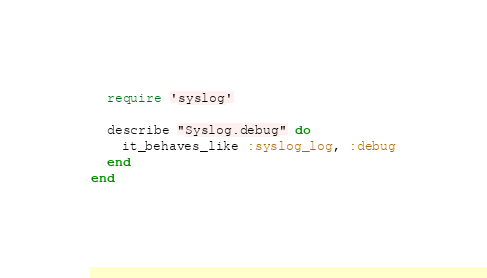Convert code to text. <code><loc_0><loc_0><loc_500><loc_500><_Ruby_>  require 'syslog'

  describe "Syslog.debug" do
    it_behaves_like :syslog_log, :debug
  end
end
</code> 